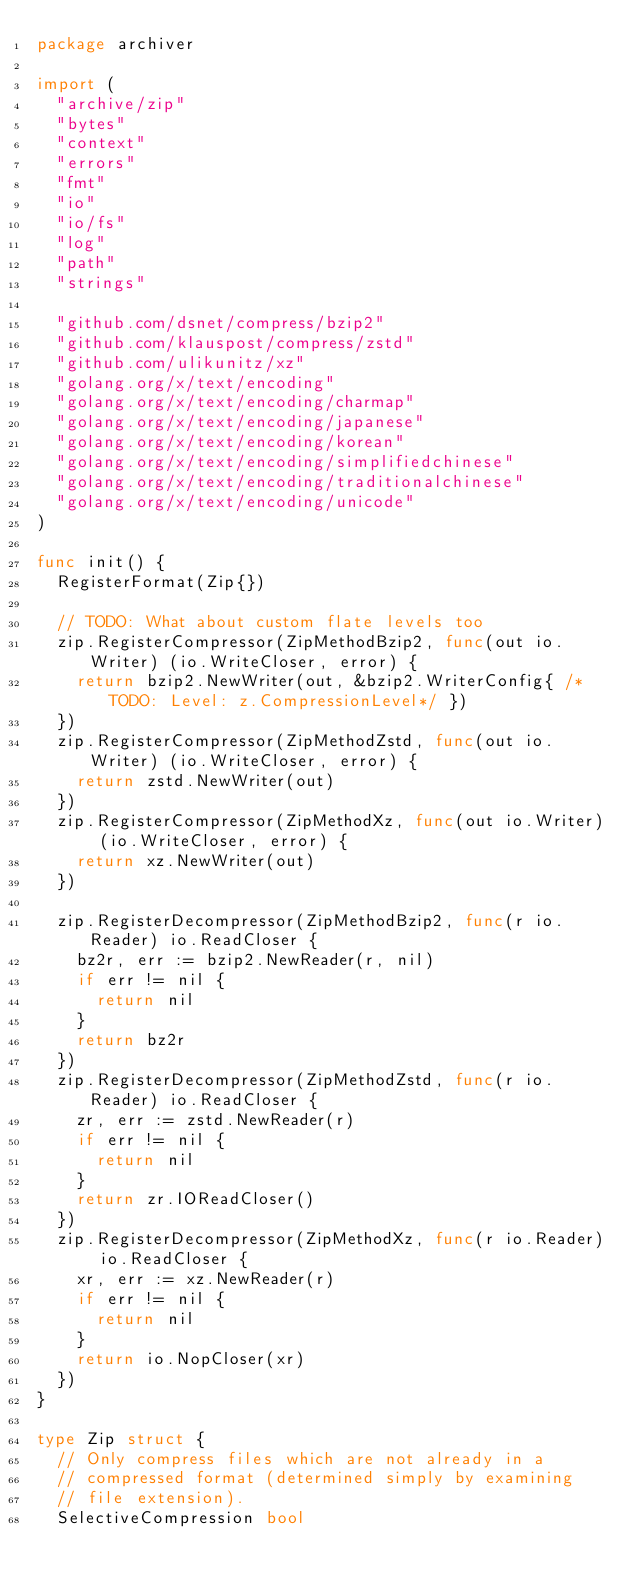<code> <loc_0><loc_0><loc_500><loc_500><_Go_>package archiver

import (
	"archive/zip"
	"bytes"
	"context"
	"errors"
	"fmt"
	"io"
	"io/fs"
	"log"
	"path"
	"strings"

	"github.com/dsnet/compress/bzip2"
	"github.com/klauspost/compress/zstd"
	"github.com/ulikunitz/xz"
	"golang.org/x/text/encoding"
	"golang.org/x/text/encoding/charmap"
	"golang.org/x/text/encoding/japanese"
	"golang.org/x/text/encoding/korean"
	"golang.org/x/text/encoding/simplifiedchinese"
	"golang.org/x/text/encoding/traditionalchinese"
	"golang.org/x/text/encoding/unicode"
)

func init() {
	RegisterFormat(Zip{})

	// TODO: What about custom flate levels too
	zip.RegisterCompressor(ZipMethodBzip2, func(out io.Writer) (io.WriteCloser, error) {
		return bzip2.NewWriter(out, &bzip2.WriterConfig{ /*TODO: Level: z.CompressionLevel*/ })
	})
	zip.RegisterCompressor(ZipMethodZstd, func(out io.Writer) (io.WriteCloser, error) {
		return zstd.NewWriter(out)
	})
	zip.RegisterCompressor(ZipMethodXz, func(out io.Writer) (io.WriteCloser, error) {
		return xz.NewWriter(out)
	})

	zip.RegisterDecompressor(ZipMethodBzip2, func(r io.Reader) io.ReadCloser {
		bz2r, err := bzip2.NewReader(r, nil)
		if err != nil {
			return nil
		}
		return bz2r
	})
	zip.RegisterDecompressor(ZipMethodZstd, func(r io.Reader) io.ReadCloser {
		zr, err := zstd.NewReader(r)
		if err != nil {
			return nil
		}
		return zr.IOReadCloser()
	})
	zip.RegisterDecompressor(ZipMethodXz, func(r io.Reader) io.ReadCloser {
		xr, err := xz.NewReader(r)
		if err != nil {
			return nil
		}
		return io.NopCloser(xr)
	})
}

type Zip struct {
	// Only compress files which are not already in a
	// compressed format (determined simply by examining
	// file extension).
	SelectiveCompression bool
</code> 